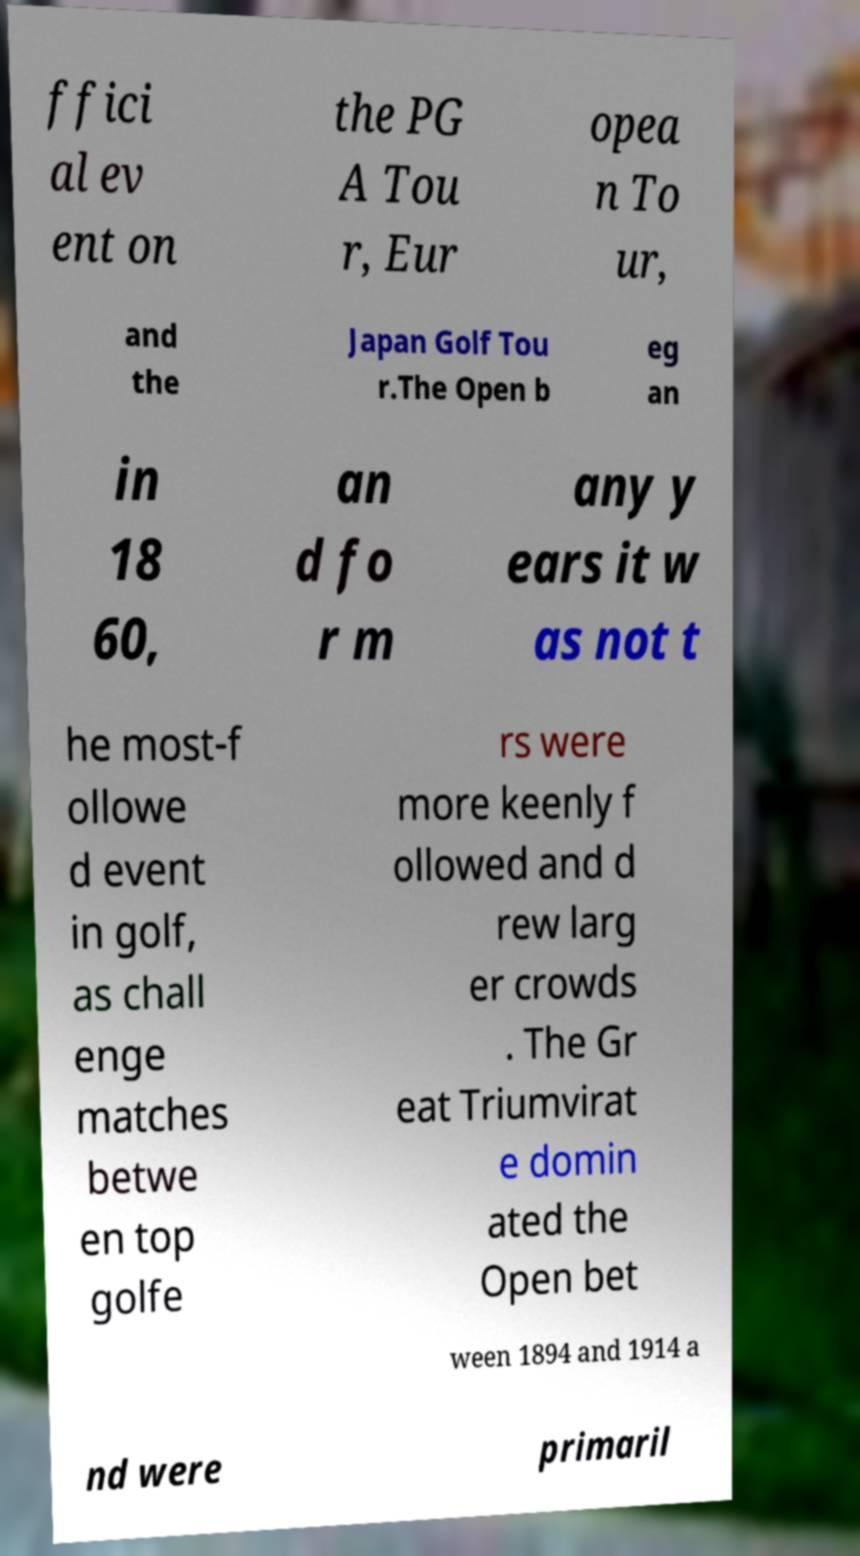Please identify and transcribe the text found in this image. ffici al ev ent on the PG A Tou r, Eur opea n To ur, and the Japan Golf Tou r.The Open b eg an in 18 60, an d fo r m any y ears it w as not t he most-f ollowe d event in golf, as chall enge matches betwe en top golfe rs were more keenly f ollowed and d rew larg er crowds . The Gr eat Triumvirat e domin ated the Open bet ween 1894 and 1914 a nd were primaril 